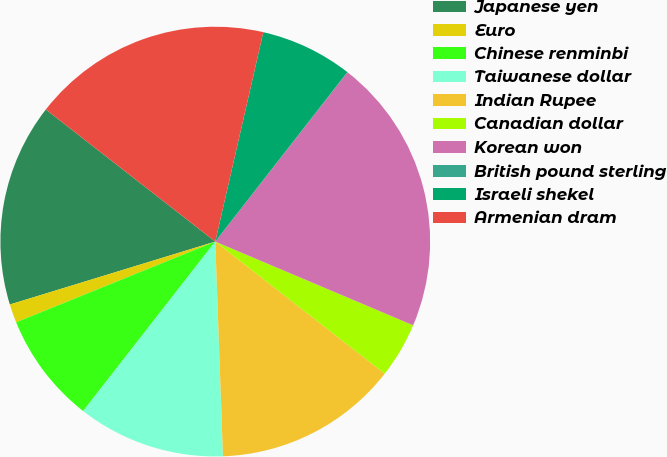Convert chart to OTSL. <chart><loc_0><loc_0><loc_500><loc_500><pie_chart><fcel>Japanese yen<fcel>Euro<fcel>Chinese renminbi<fcel>Taiwanese dollar<fcel>Indian Rupee<fcel>Canadian dollar<fcel>Korean won<fcel>British pound sterling<fcel>Israeli shekel<fcel>Armenian dram<nl><fcel>15.27%<fcel>1.4%<fcel>8.33%<fcel>11.11%<fcel>13.89%<fcel>4.17%<fcel>20.82%<fcel>0.01%<fcel>6.95%<fcel>18.05%<nl></chart> 